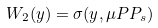<formula> <loc_0><loc_0><loc_500><loc_500>W _ { 2 } ( y ) = \sigma ( y , \mu P P _ { s } )</formula> 